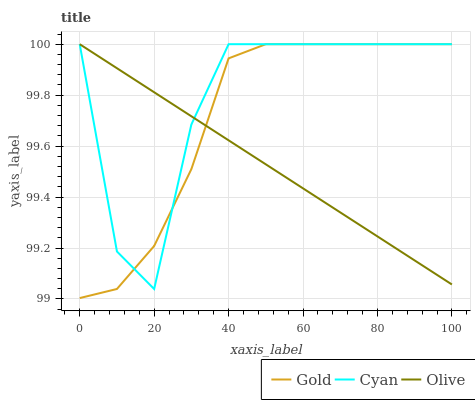Does Olive have the minimum area under the curve?
Answer yes or no. Yes. Does Cyan have the maximum area under the curve?
Answer yes or no. Yes. Does Gold have the minimum area under the curve?
Answer yes or no. No. Does Gold have the maximum area under the curve?
Answer yes or no. No. Is Olive the smoothest?
Answer yes or no. Yes. Is Cyan the roughest?
Answer yes or no. Yes. Is Gold the smoothest?
Answer yes or no. No. Is Gold the roughest?
Answer yes or no. No. Does Gold have the lowest value?
Answer yes or no. Yes. Does Cyan have the lowest value?
Answer yes or no. No. Does Gold have the highest value?
Answer yes or no. Yes. Does Olive intersect Cyan?
Answer yes or no. Yes. Is Olive less than Cyan?
Answer yes or no. No. Is Olive greater than Cyan?
Answer yes or no. No. 